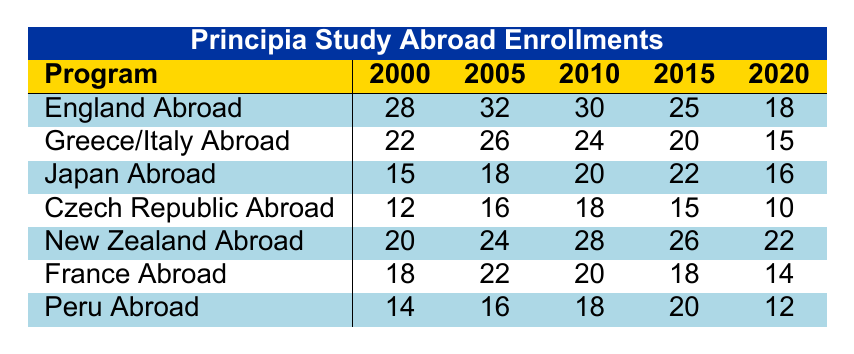What was the enrollment for the "Japan Abroad" program in 2010? The enrollment for the "Japan Abroad" program in 2010 is directly given in the table, which shows 20 students.
Answer: 20 Which study abroad program had the highest enrollment in 2005? The highest enrollment in 2005 can be found by comparing all enrollment numbers for that year. The "New Zealand Abroad" program had 24, which is higher than all other programs listed.
Answer: New Zealand Abroad What was the total enrollment for "Peru Abroad" from 2000 to 2020? To find the total enrollment for "Peru Abroad," we sum its enrollments from 2000 (14), 2005 (16), 2010 (18), 2015 (20), and 2020 (12): 14 + 16 + 18 + 20 + 12 = 80.
Answer: 80 Did the enrollment for "England Abroad" decrease over the years? We compare the enrollments for "England Abroad" from year to year: 28 (2000) → 32 (2005) → 30 (2010) → 25 (2015) → 18 (2020). Since the trend goes down after 2005, we confirm there was a decrease overall.
Answer: Yes What is the average enrollment of the "Czech Republic Abroad" program across the years? We take the enrollments for "Czech Republic Abroad" (12, 16, 18, 15, 10), sum these values (12 + 16 + 18 + 15 + 10 = 71), and divide by the number of years (5): 71 / 5 = 14.2.
Answer: 14.2 Which program had the most consistent enrollment numbers across the years? To determine consistency, we look for the program with the smallest fluctuation in enrollment numbers. The "Peru Abroad" program showed enrollments of 14, 16, 18, 20, and 12, indicating a gradual and minor variation compared to others.
Answer: Peru Abroad What was the enrollment in the "Greece/Italy Abroad" program in 2020, and how does it compare to its enrollment in 2000? The enrollment for "Greece/Italy Abroad" in 2020 is 15, while in 2000, it was 22. The comparison shows a decrease of 7 enrollments from 2000 to 2020.
Answer: 15, decreased by 7 If the enrollments of "France Abroad" for 2015 and 2020 are combined, how does it compare to the enrollment for "New Zealand Abroad" in 2010? The combined enrollment for "France Abroad" in 2015 (18) and 2020 (14) is 32. The enrollments for "New Zealand Abroad" in 2010 is 28. Comparing these shows that 32 is greater than 28.
Answer: Greater than What percentage did "Japan Abroad" decrease in enrollment from 2015 to 2020? The enrollment for "Japan Abroad" was 22 in 2015 and decreased to 16 in 2020. The decrease is 22 - 16 = 6. To find the percentage decrease, we calculate (6 / 22) * 100, which equals approximately 27.27%.
Answer: 27.27% Which program experienced the largest enrollment drop from 2000 to 2020? To find this, we calculate the difference in enrollment for each program in 2000 and 2020. "England Abroad" dropped from 28 to 18 (-10), "Greece/Italy Abroad" from 22 to 15 (-7), and so on. "England Abroad" had the largest drop of 10.
Answer: England Abroad 